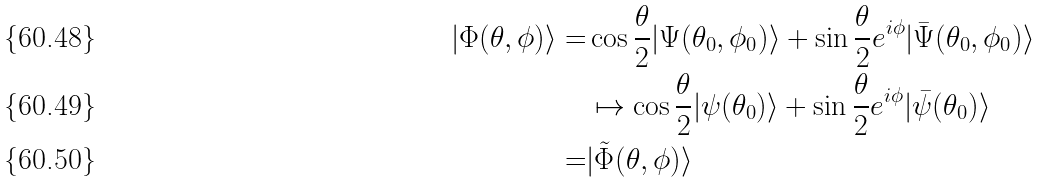<formula> <loc_0><loc_0><loc_500><loc_500>| \Phi ( \theta , \phi ) \rangle = & \cos \frac { \theta } { 2 } | \Psi ( \theta _ { 0 } , \phi _ { 0 } ) \rangle + \sin \frac { \theta } { 2 } e ^ { i \phi } | { \bar { \Psi } } ( \theta _ { 0 } , \phi _ { 0 } ) \rangle \\ & \mapsto \cos \frac { \theta } { 2 } | \psi ( \theta _ { 0 } ) \rangle + \sin \frac { \theta } { 2 } e ^ { i \phi } | { \bar { \psi } } ( \theta _ { 0 } ) \rangle \\ = & | { \tilde { \Phi } } ( \theta , \phi ) \rangle</formula> 